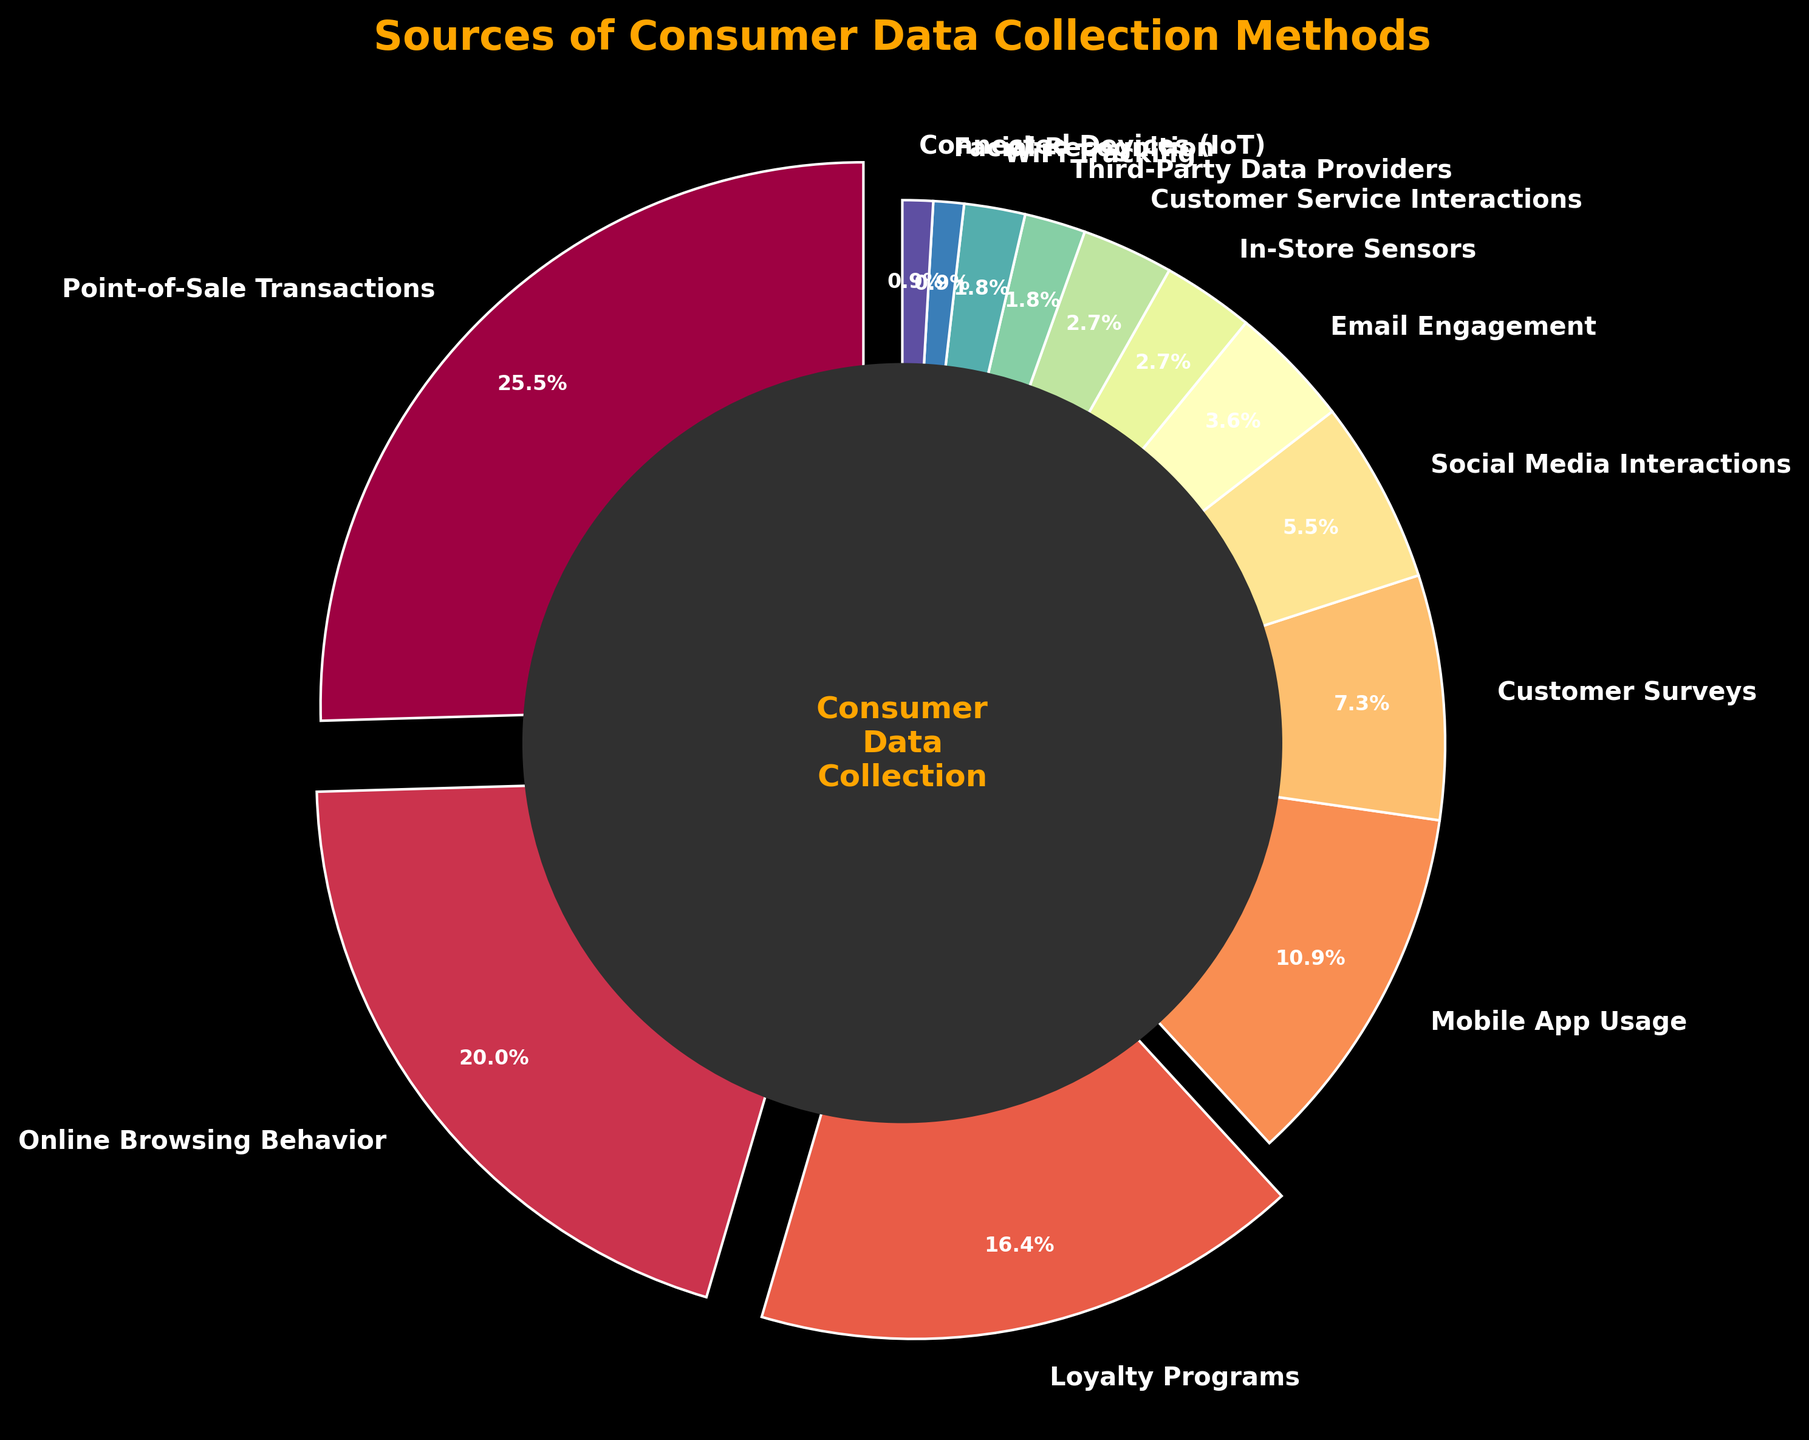What percentage of consumer data is collected from loyalty programs? Refer to the loyalty programs segment which is labeled on the pie chart. The corresponding percentage is provided as part of the label.
Answer: 18% Which source contributes more to consumer data collection: social media interactions or customer surveys? Compare the labeled percentages for social media interactions and customer surveys. Social media interactions have 6% and customer surveys have 8%.
Answer: Customer surveys What's the combined percentage of consumer data collected from email engagement and WiFi tracking? Add the percentages of email engagement (4%) and WiFi tracking (2%). The sum is 4 + 2 = 6.
Answer: 6% What is the least used method for collecting consumer data and what is its percentage? Find the smallest percentage value, which is 1%, and the corresponding category is labeled.
Answer: Connected Devices (IoT) and Facial Recognition at 1% Which method accounts for a larger share of data collection: Online Browsing Behavior or Mobile App Usage? Compare the labeled percentages for online browsing behavior and mobile app usage. Online browsing behavior is 22% and mobile app usage is 12%.
Answer: Online Browsing Behavior What percentage is represented by the combined segments of sources each contributing 2% or less? Sum the percentages of sources with 2% or less: Third-Party Data Providers (2%), WiFi Tracking (2%), Facial Recognition (1%), and Connected Devices (IoT) (1%). The sum is 2 + 2 + 1 + 1 = 6.
Answer: 6% Which data collection method has a visually distinct segment separation due to the "explode" effect and what does this indicate? Identify the segment that is separated from the rest of the pie chart, typically indicating a high percentage. The exploded segment is point-of-sale transactions, which indicates a significant share.
Answer: Point-of-Sale Transactions What is the combined percentage of the top two data collection methods? Add the percentages of the highest two segments: Point-of-Sale Transactions (28%) and Online Browsing Behavior (22%). The sum is 28 + 22 = 50.
Answer: 50% Which method has a higher percentage: Mobile App Usage or Customer Service Interactions? Compare the labeled percentages for mobile app usage and customer service interactions. Mobile app usage is 12% and customer service interactions is 3%.
Answer: Mobile App Usage 